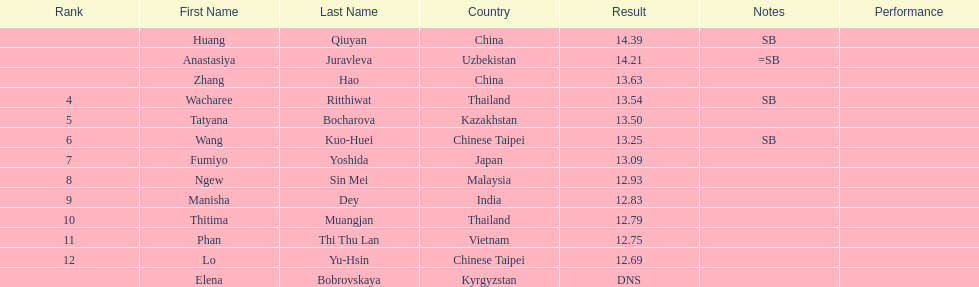Which country had the most competitors ranked in the top three in the event? China. 